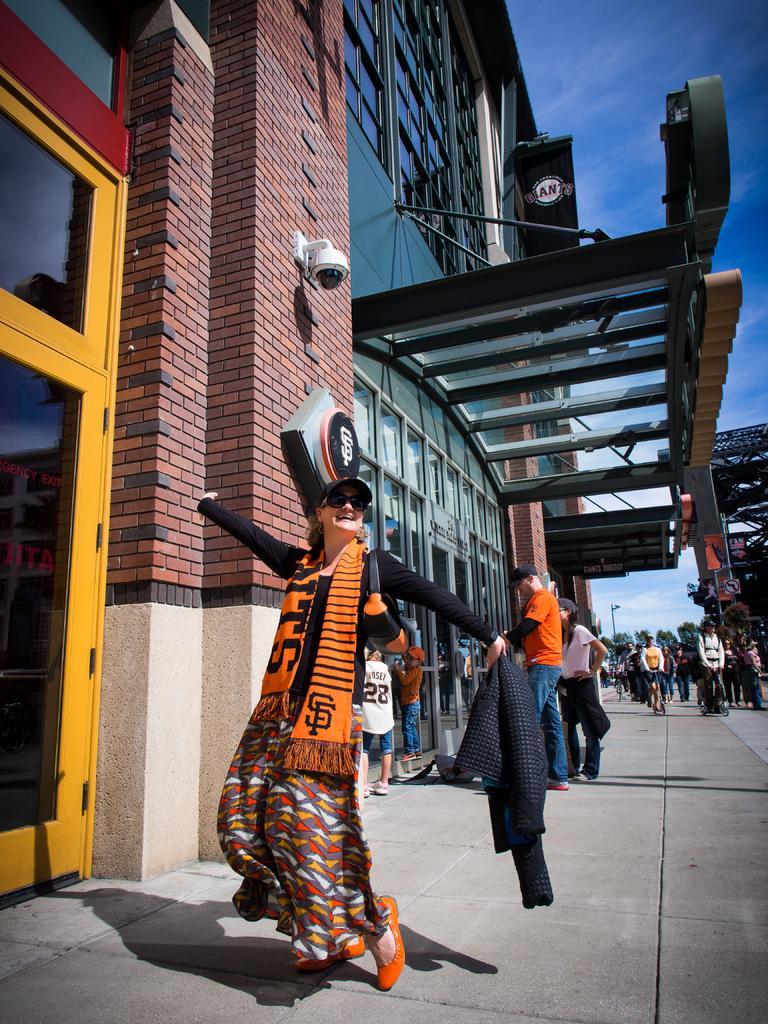Describe this image in one or two sentences. In this image we can see a few people, some of them are riding on the skateboards, a lady is holding a blazer, there is a door, CC camera, light pole, buildings, windows, roof top, also we can see the sky. 